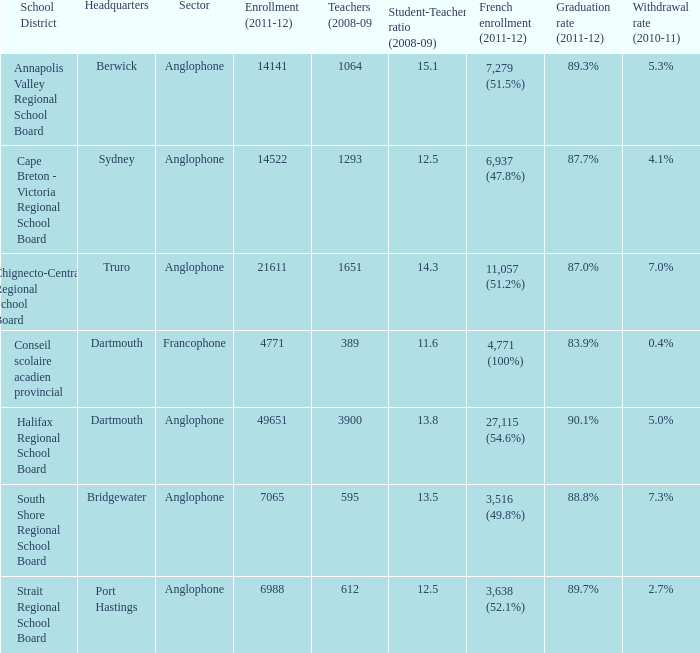What is the dropout rate in the school district whose headquarters are situated in truro? 7.0%. 